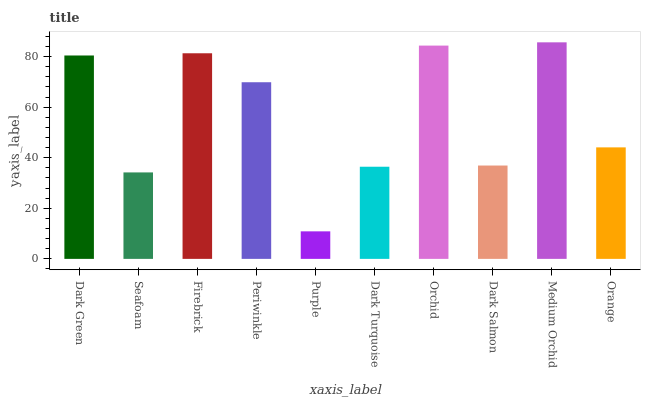Is Seafoam the minimum?
Answer yes or no. No. Is Seafoam the maximum?
Answer yes or no. No. Is Dark Green greater than Seafoam?
Answer yes or no. Yes. Is Seafoam less than Dark Green?
Answer yes or no. Yes. Is Seafoam greater than Dark Green?
Answer yes or no. No. Is Dark Green less than Seafoam?
Answer yes or no. No. Is Periwinkle the high median?
Answer yes or no. Yes. Is Orange the low median?
Answer yes or no. Yes. Is Seafoam the high median?
Answer yes or no. No. Is Firebrick the low median?
Answer yes or no. No. 